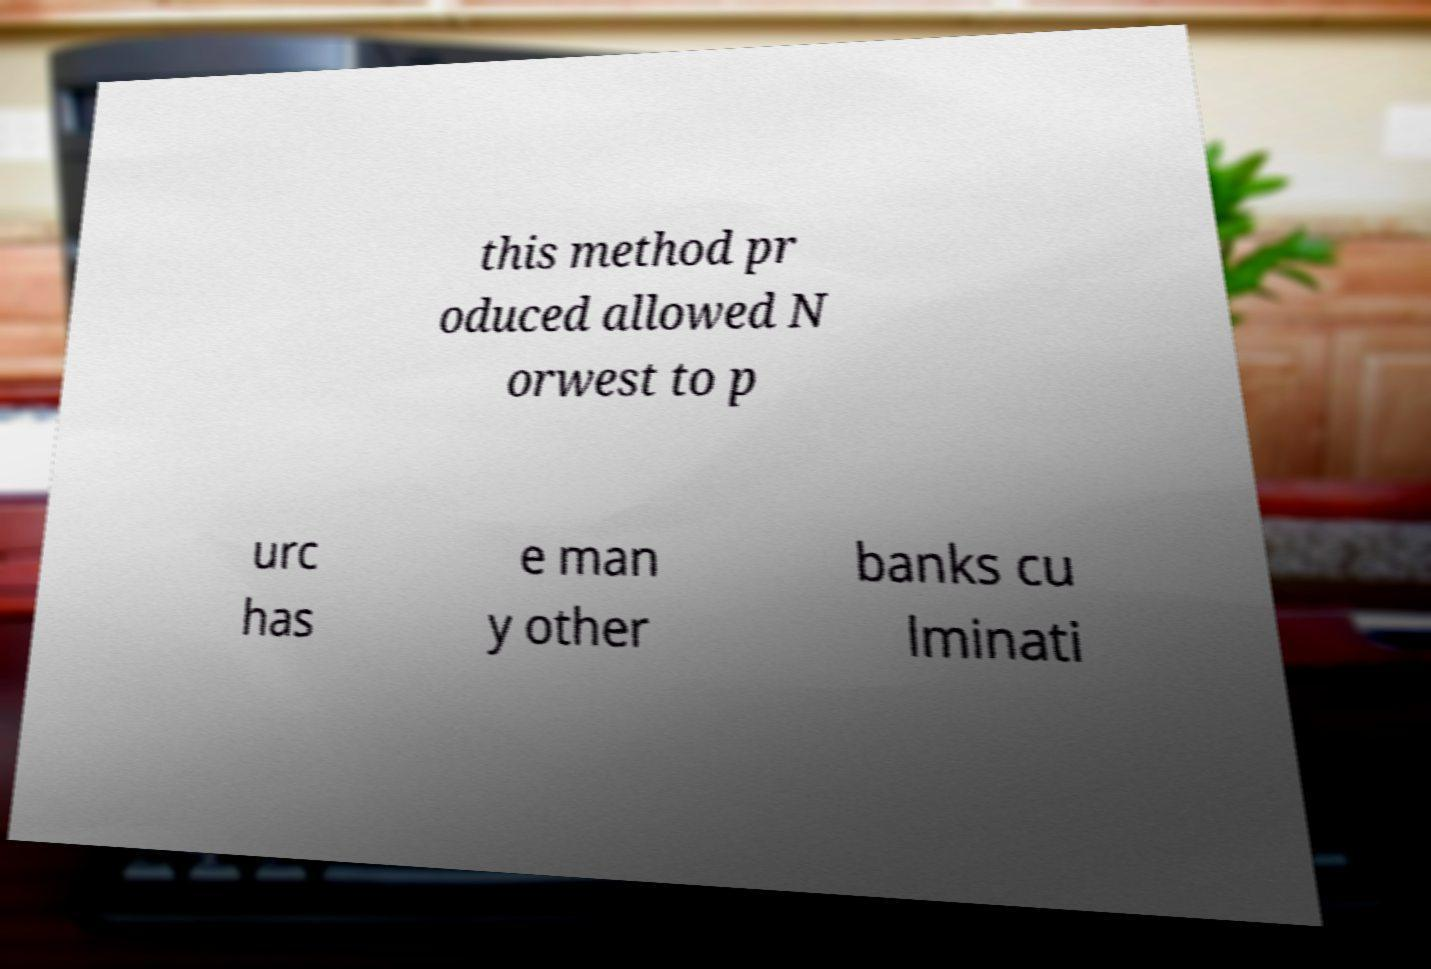Please read and relay the text visible in this image. What does it say? this method pr oduced allowed N orwest to p urc has e man y other banks cu lminati 